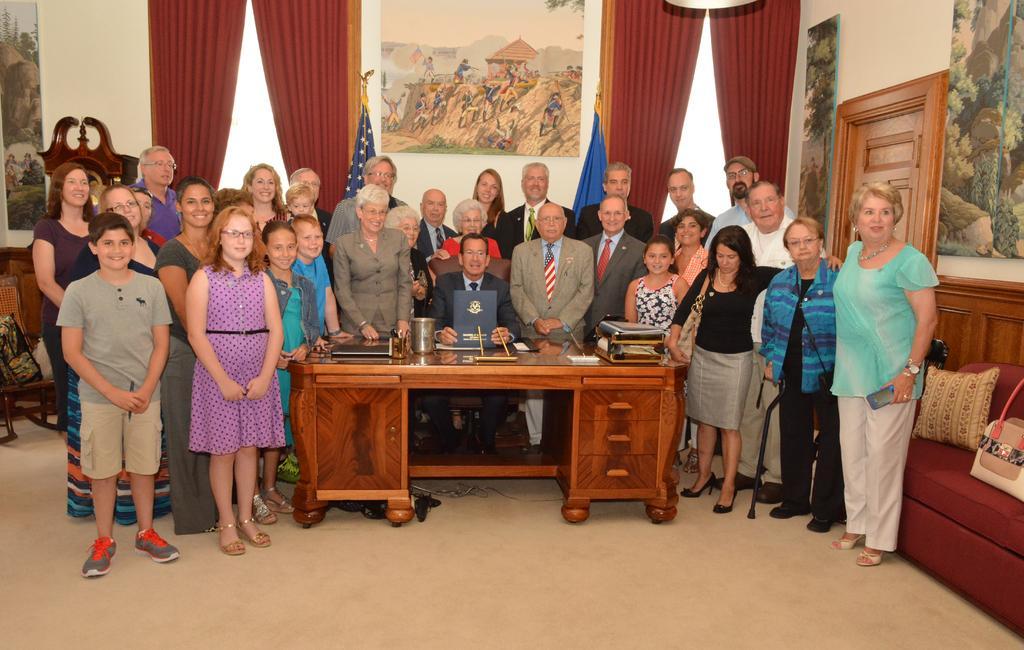How would you summarize this image in a sentence or two? In this picture we can see some persons are standing on the floor. This is table. On the table there books, and a jar. This is sofa and there is a pillow. On the background there is a wall and these are the frames. Here we can see a curtain and this is door. 